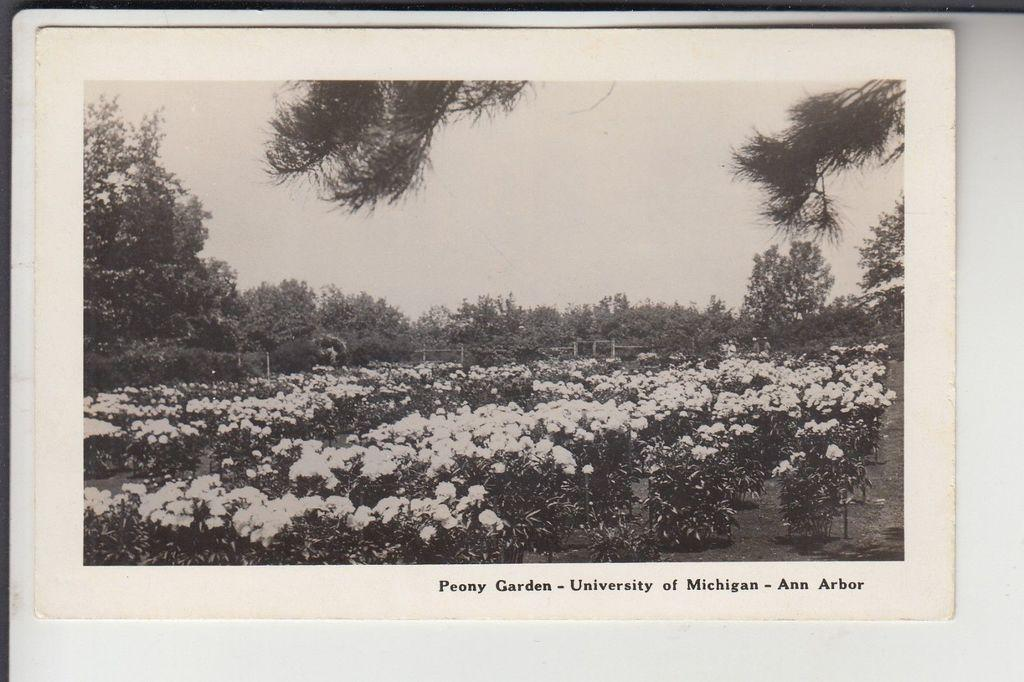What type of photography is the image? The image is a black and white photography. What natural elements can be seen in the image? The photograph contains the sky, trees, plants, and bushes. What part of the landscape is visible in the image? The ground is visible in the photograph. What type of branch is the spring attached to in the image? There is no branch or spring present in the image; it is a black and white photograph featuring natural elements like the sky, trees, plants, bushes, and the ground. 